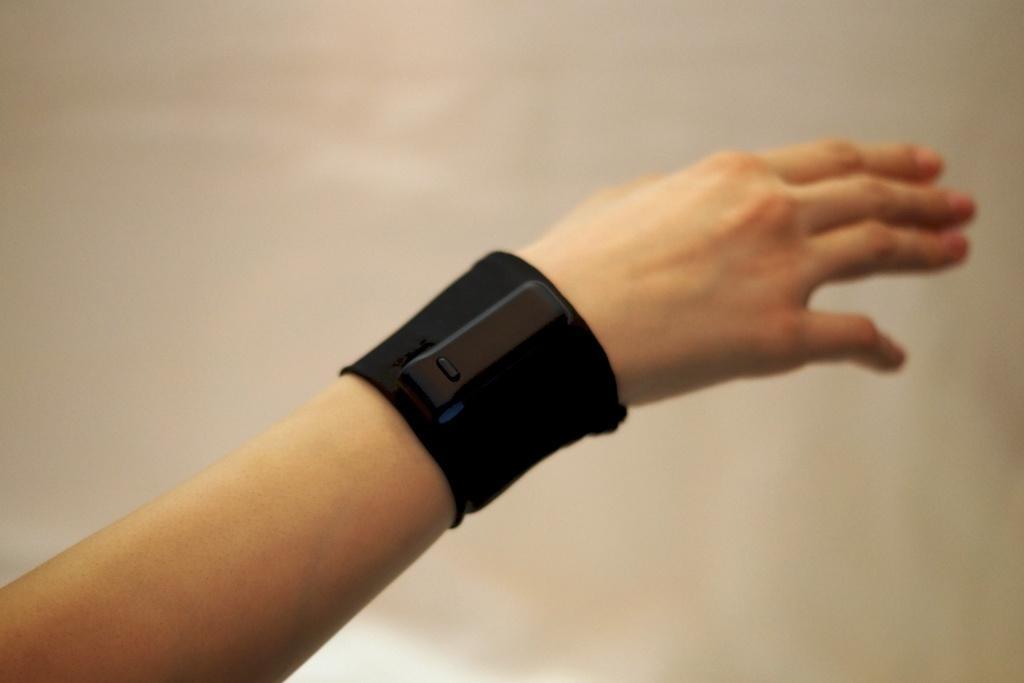Can you describe this image briefly? In the center of the image there is a black color wrist band on the person's hand. 